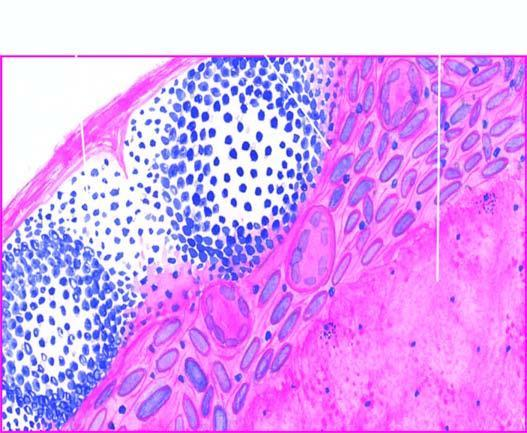what is there?
Answer the question using a single word or phrase. Eosinophilic 